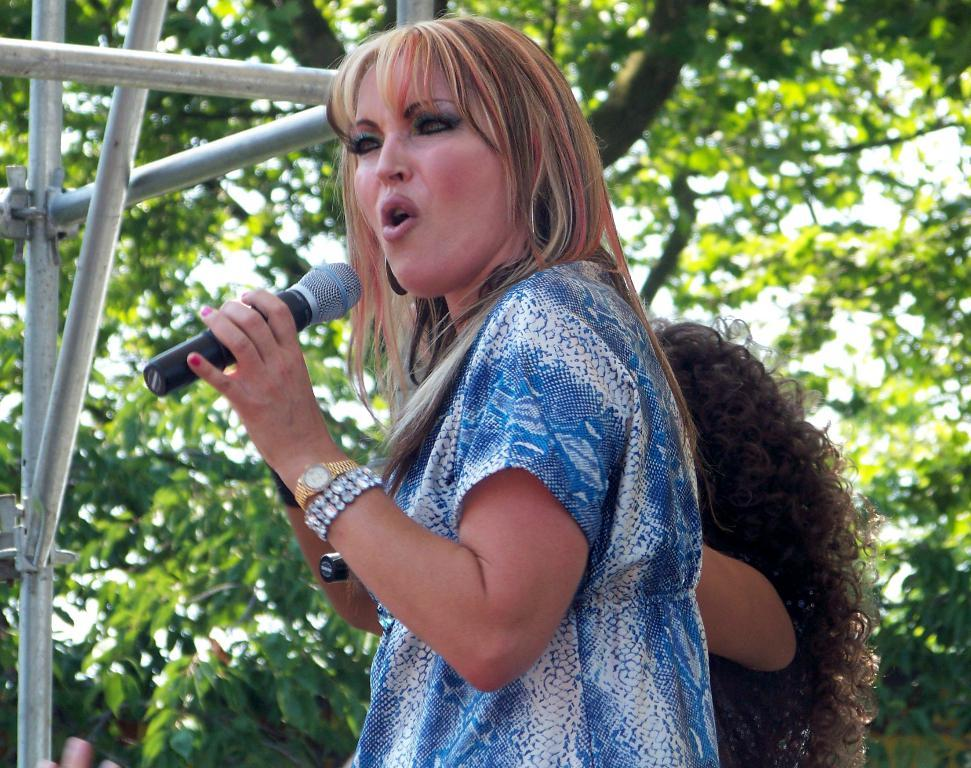Who is the main subject in the image? There is a woman in the image. What is the woman doing in the image? The woman is standing and holding a mic in her hand. Can you describe the person behind the woman? There is another person behind the woman, but their appearance or actions are not specified. What can be seen in the background of the image? There are trees visible in the background of the image. What type of growth can be seen on the trees in the image? There is no indication of growth on the trees in the image, as the focus is on the woman and the person behind her. 